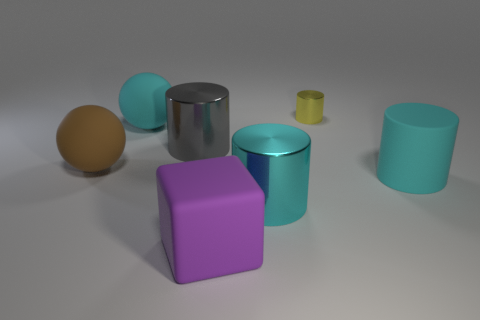Which object in the image looks the heaviest, and can you describe its color and shape? The object that appears the heaviest is the large brown sphere. Its color resembles that of rust or dark mustard, and it has a perfectly spherical shape, hinting at solidity and weight. 